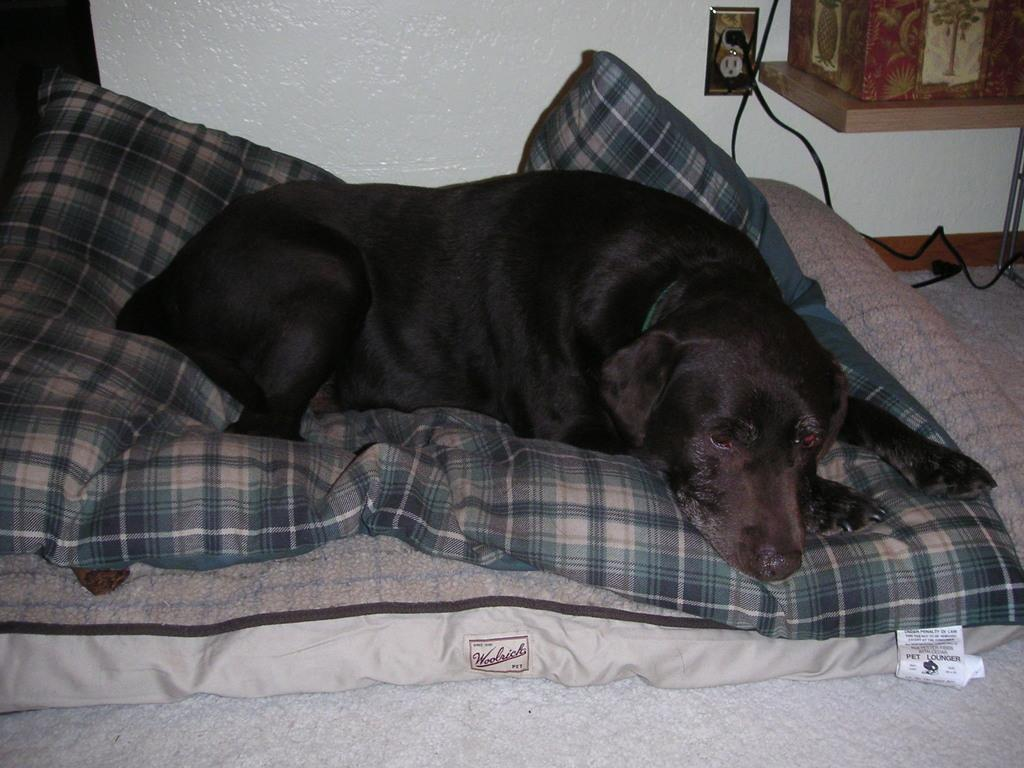What animal can be seen in the image? There is a dog in the image. What is the dog doing in the image? The dog is sleeping on a bed. What furniture is present in the image? There is a bed in the image. What can be seen in the background of the image? There is a wall, a wire, a plug, and some boxes in the background of the image. What type of tree can be seen in the image? There is no tree present in the image. What kind of apparel is the dog wearing in the image? The dog is not wearing any apparel in the image. 